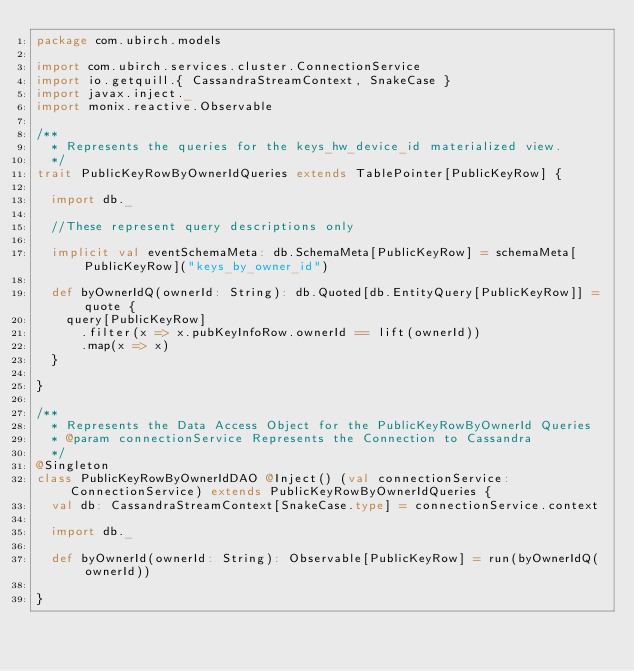<code> <loc_0><loc_0><loc_500><loc_500><_Scala_>package com.ubirch.models

import com.ubirch.services.cluster.ConnectionService
import io.getquill.{ CassandraStreamContext, SnakeCase }
import javax.inject._
import monix.reactive.Observable

/**
  * Represents the queries for the keys_hw_device_id materialized view.
  */
trait PublicKeyRowByOwnerIdQueries extends TablePointer[PublicKeyRow] {

  import db._

  //These represent query descriptions only

  implicit val eventSchemaMeta: db.SchemaMeta[PublicKeyRow] = schemaMeta[PublicKeyRow]("keys_by_owner_id")

  def byOwnerIdQ(ownerId: String): db.Quoted[db.EntityQuery[PublicKeyRow]] = quote {
    query[PublicKeyRow]
      .filter(x => x.pubKeyInfoRow.ownerId == lift(ownerId))
      .map(x => x)
  }

}

/**
  * Represents the Data Access Object for the PublicKeyRowByOwnerId Queries
  * @param connectionService Represents the Connection to Cassandra
  */
@Singleton
class PublicKeyRowByOwnerIdDAO @Inject() (val connectionService: ConnectionService) extends PublicKeyRowByOwnerIdQueries {
  val db: CassandraStreamContext[SnakeCase.type] = connectionService.context

  import db._

  def byOwnerId(ownerId: String): Observable[PublicKeyRow] = run(byOwnerIdQ(ownerId))

}
</code> 